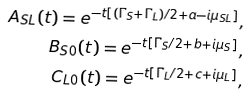Convert formula to latex. <formula><loc_0><loc_0><loc_500><loc_500>A _ { S L } ( t ) = e ^ { - t \left [ ( \Gamma _ { S } + \Gamma _ { L } ) / 2 + a - i \mu _ { S L } \right ] } , \\ B _ { S 0 } ( t ) = e ^ { - t \left [ \Gamma _ { S } / 2 + b + i \mu _ { S } \right ] } , \\ C _ { L 0 } ( t ) = e ^ { - t \left [ \Gamma _ { L } / 2 + c + i \mu _ { L } \right ] } ,</formula> 